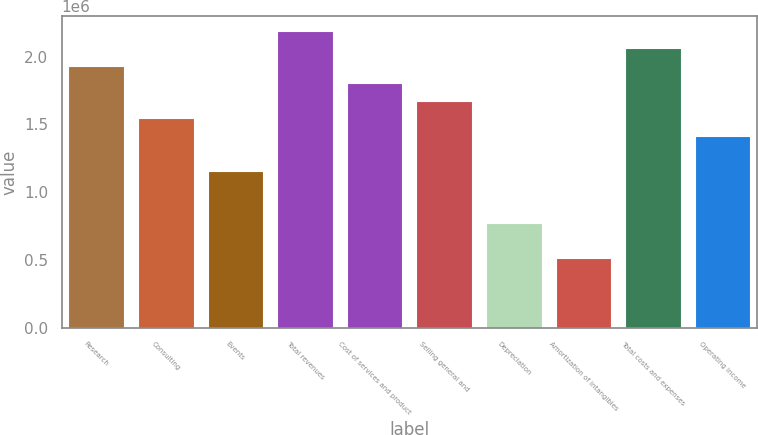Convert chart. <chart><loc_0><loc_0><loc_500><loc_500><bar_chart><fcel>Research<fcel>Consulting<fcel>Events<fcel>Total revenues<fcel>Cost of services and product<fcel>Selling general and<fcel>Depreciation<fcel>Amortization of intangibles<fcel>Total costs and expenses<fcel>Operating income<nl><fcel>1.93268e+06<fcel>1.54614e+06<fcel>1.15961e+06<fcel>2.19037e+06<fcel>1.80384e+06<fcel>1.67499e+06<fcel>773073<fcel>515382<fcel>2.06153e+06<fcel>1.4173e+06<nl></chart> 